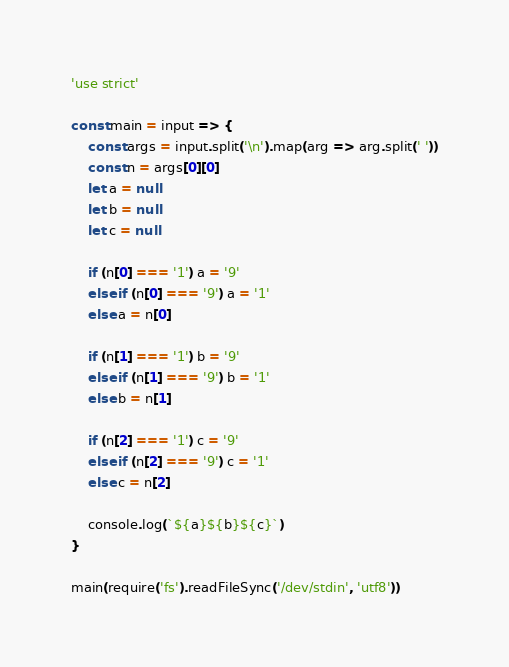<code> <loc_0><loc_0><loc_500><loc_500><_JavaScript_>'use strict'

const main = input => {
	const args = input.split('\n').map(arg => arg.split(' '))
	const n = args[0][0]
	let a = null
	let b = null
	let c = null

	if (n[0] === '1') a = '9'
	else if (n[0] === '9') a = '1'
	else a = n[0]

	if (n[1] === '1') b = '9'
	else if (n[1] === '9') b = '1'
	else b = n[1]

	if (n[2] === '1') c = '9'
	else if (n[2] === '9') c = '1'
	else c = n[2]

	console.log(`${a}${b}${c}`)
}

main(require('fs').readFileSync('/dev/stdin', 'utf8'))
</code> 